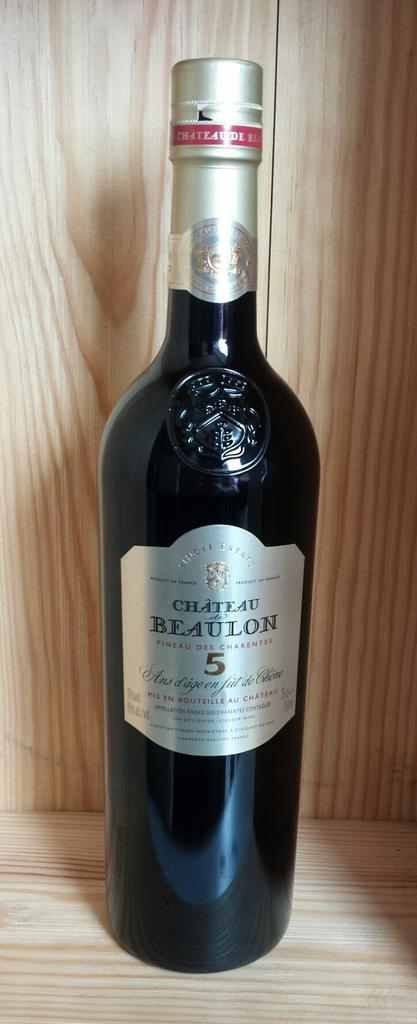<image>
Render a clear and concise summary of the photo. Bottle of wine with the words Beaulon 5 wrote on the front of it 